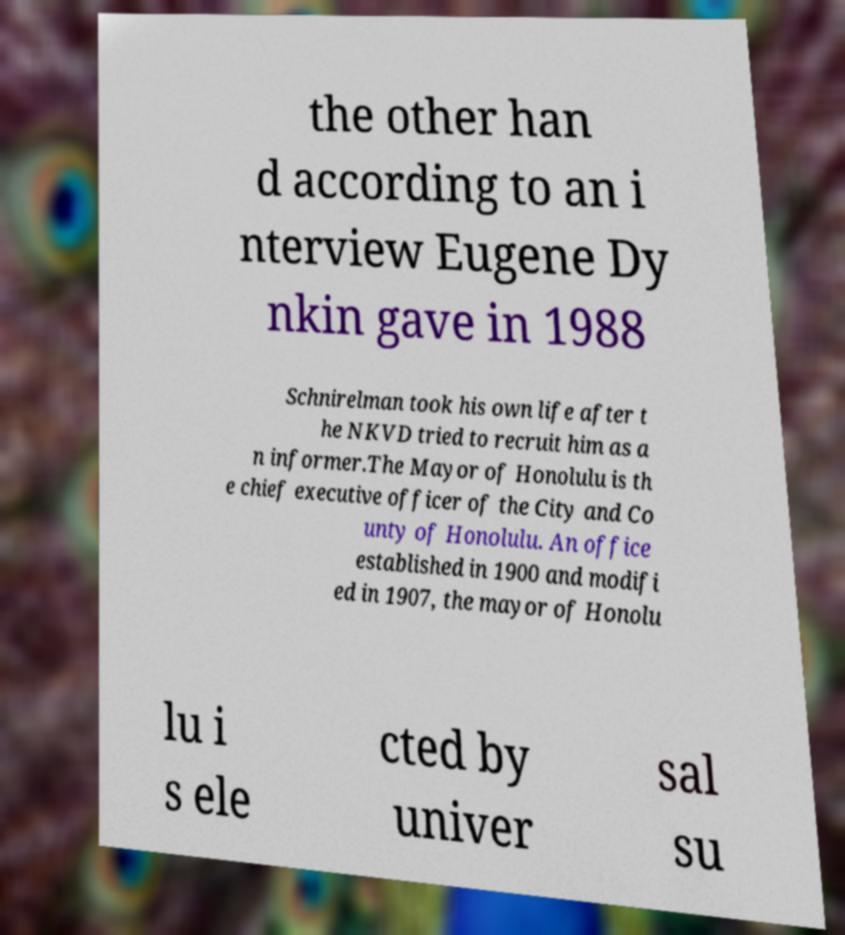There's text embedded in this image that I need extracted. Can you transcribe it verbatim? the other han d according to an i nterview Eugene Dy nkin gave in 1988 Schnirelman took his own life after t he NKVD tried to recruit him as a n informer.The Mayor of Honolulu is th e chief executive officer of the City and Co unty of Honolulu. An office established in 1900 and modifi ed in 1907, the mayor of Honolu lu i s ele cted by univer sal su 